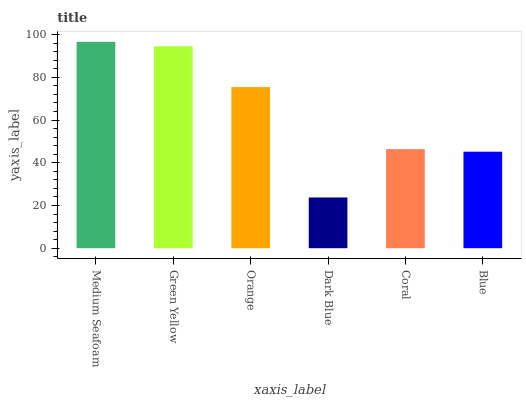Is Dark Blue the minimum?
Answer yes or no. Yes. Is Medium Seafoam the maximum?
Answer yes or no. Yes. Is Green Yellow the minimum?
Answer yes or no. No. Is Green Yellow the maximum?
Answer yes or no. No. Is Medium Seafoam greater than Green Yellow?
Answer yes or no. Yes. Is Green Yellow less than Medium Seafoam?
Answer yes or no. Yes. Is Green Yellow greater than Medium Seafoam?
Answer yes or no. No. Is Medium Seafoam less than Green Yellow?
Answer yes or no. No. Is Orange the high median?
Answer yes or no. Yes. Is Coral the low median?
Answer yes or no. Yes. Is Coral the high median?
Answer yes or no. No. Is Orange the low median?
Answer yes or no. No. 